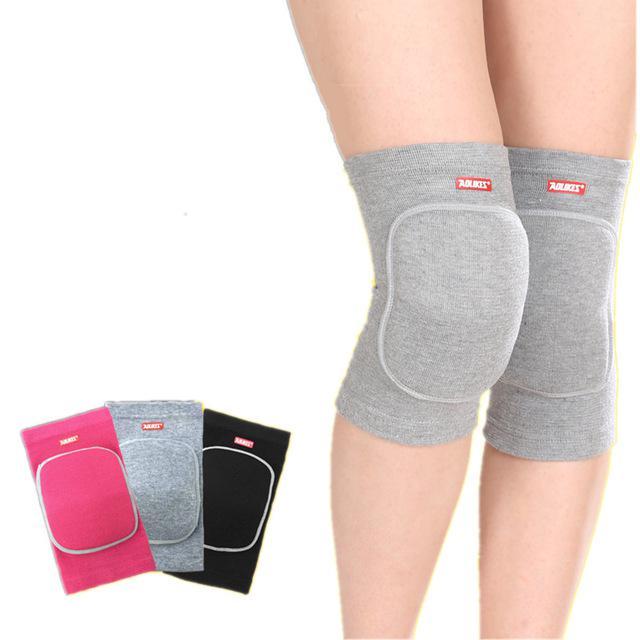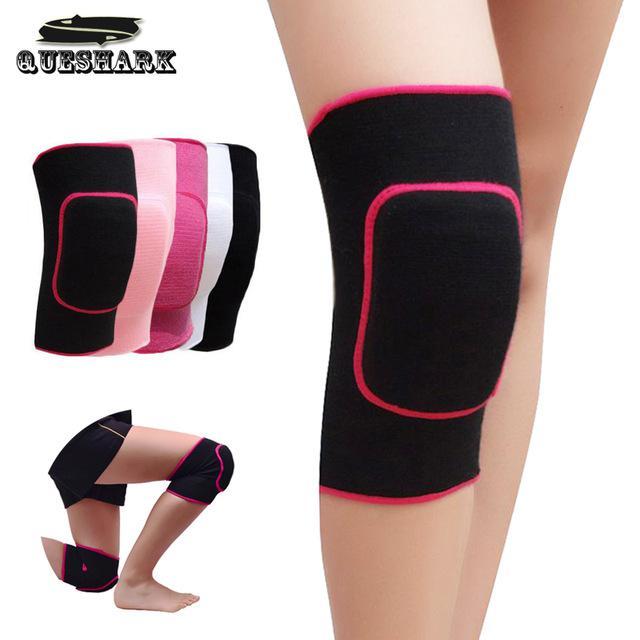The first image is the image on the left, the second image is the image on the right. Evaluate the accuracy of this statement regarding the images: "There is at least one unworn knee pad to the right of a model's legs.". Is it true? Answer yes or no. No. The first image is the image on the left, the second image is the image on the right. Given the left and right images, does the statement "Each image contains a pair of legs with the leg on the left bent and overlapping the right leg, and each image includes at least one hot pink knee pad." hold true? Answer yes or no. Yes. 